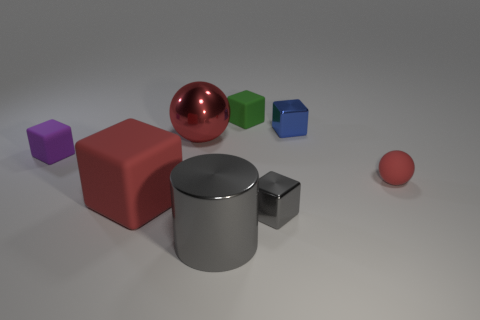Subtract all green cubes. How many cubes are left? 4 Subtract all brown cubes. Subtract all green cylinders. How many cubes are left? 5 Add 2 gray things. How many objects exist? 10 Subtract all blocks. How many objects are left? 3 Subtract all small gray shiny cubes. Subtract all metal cylinders. How many objects are left? 6 Add 1 big red matte things. How many big red matte things are left? 2 Add 4 gray blocks. How many gray blocks exist? 5 Subtract 1 red balls. How many objects are left? 7 